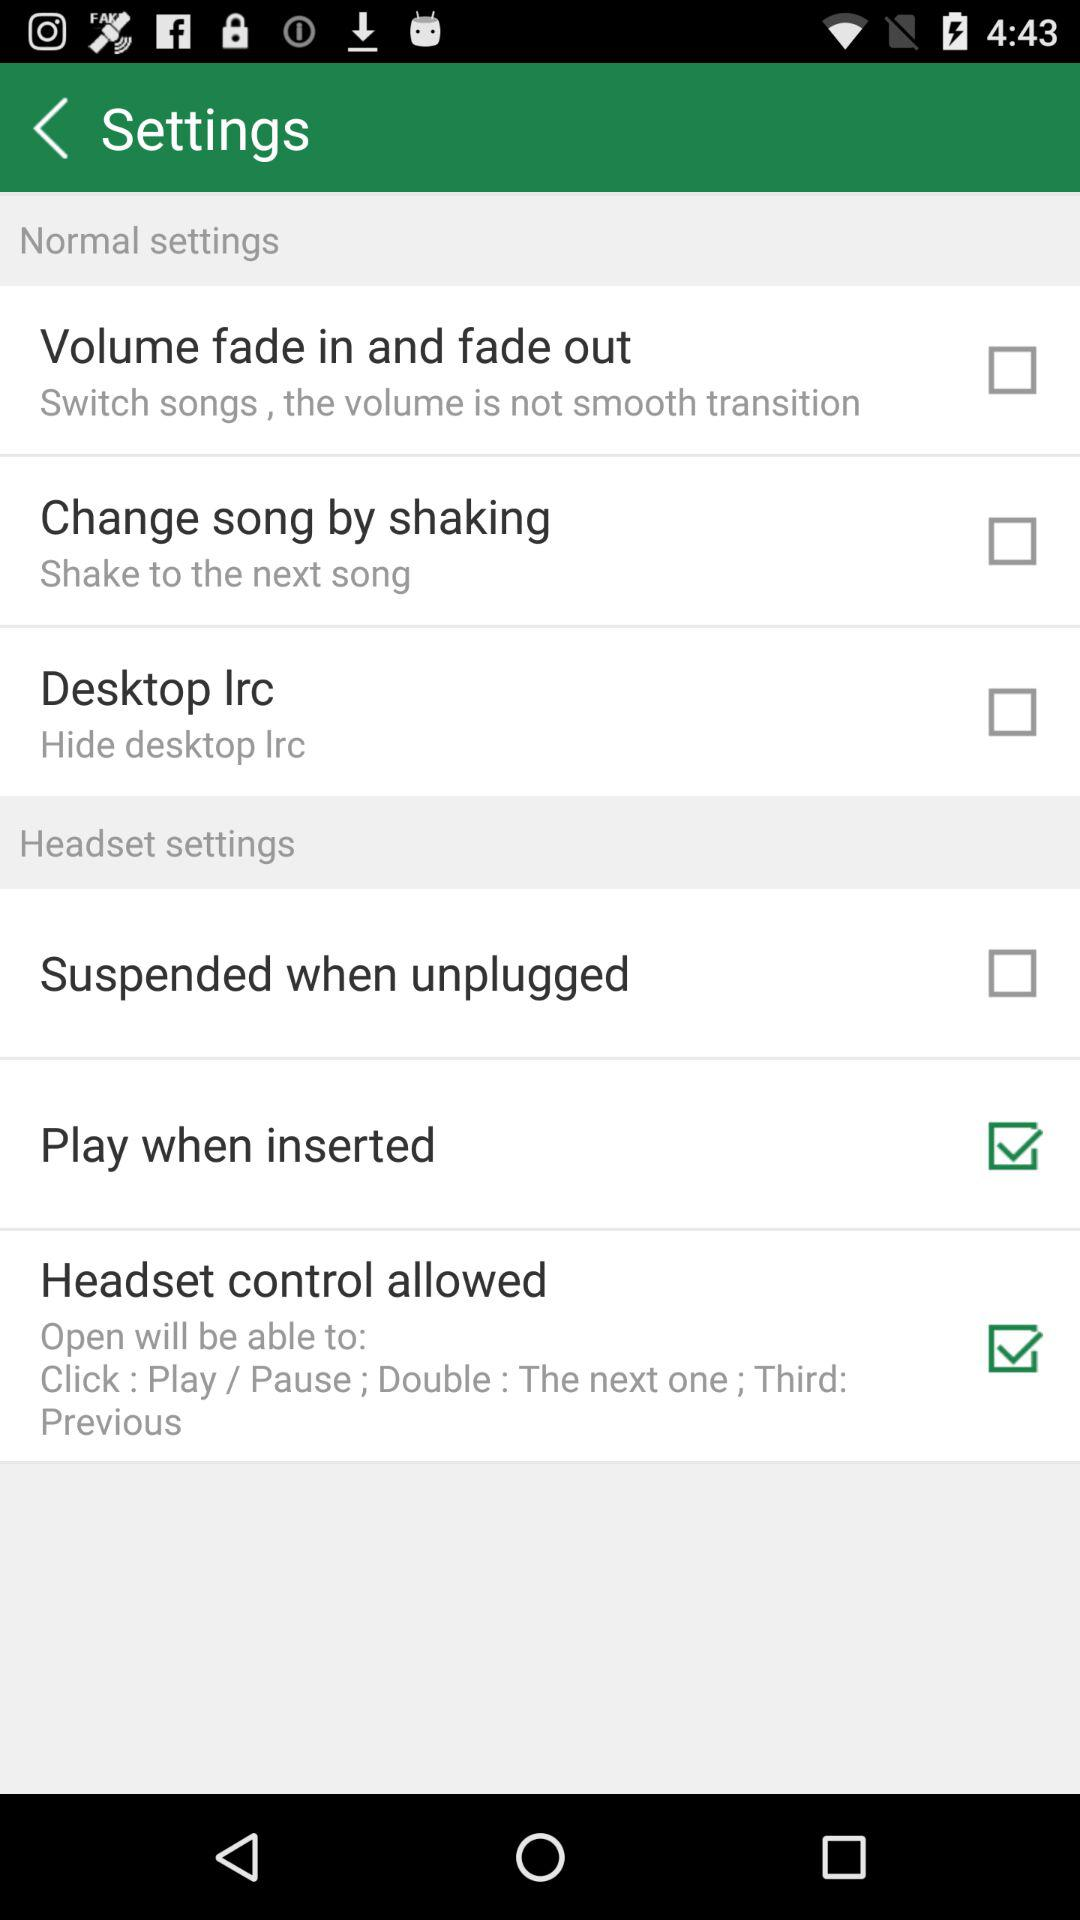What is the current status of the "Volume fade in and fade out" setting? The current status is "off". 